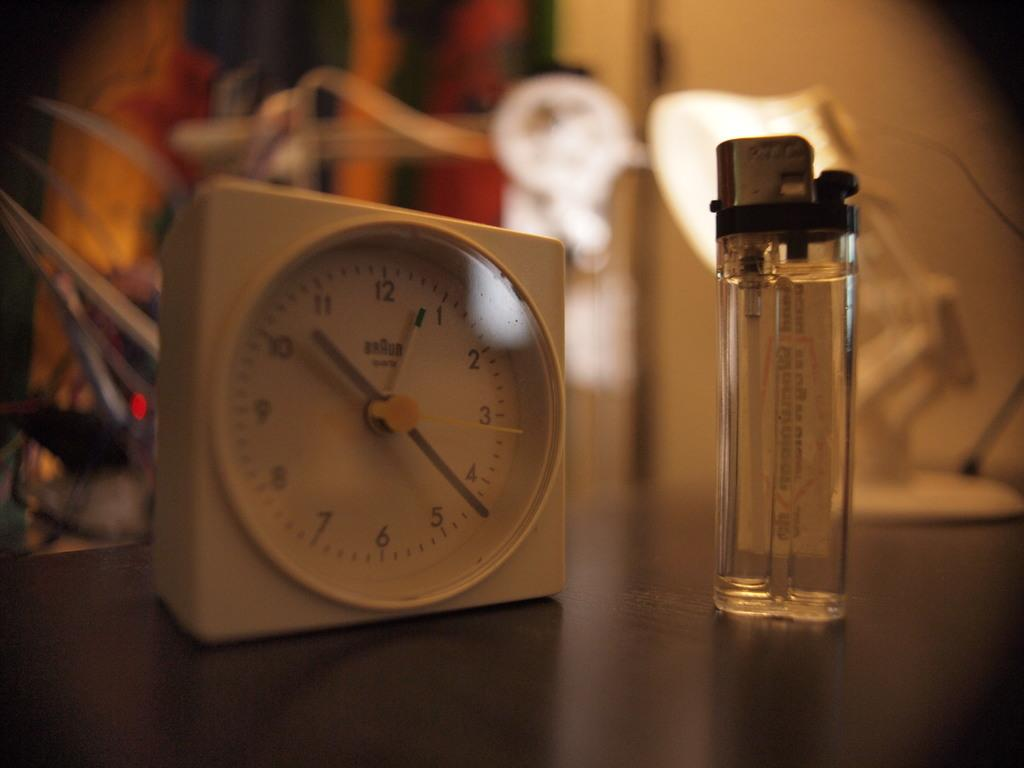<image>
Summarize the visual content of the image. A white, square BRAUN clock sits on a wooden surface next to a clear lighter 